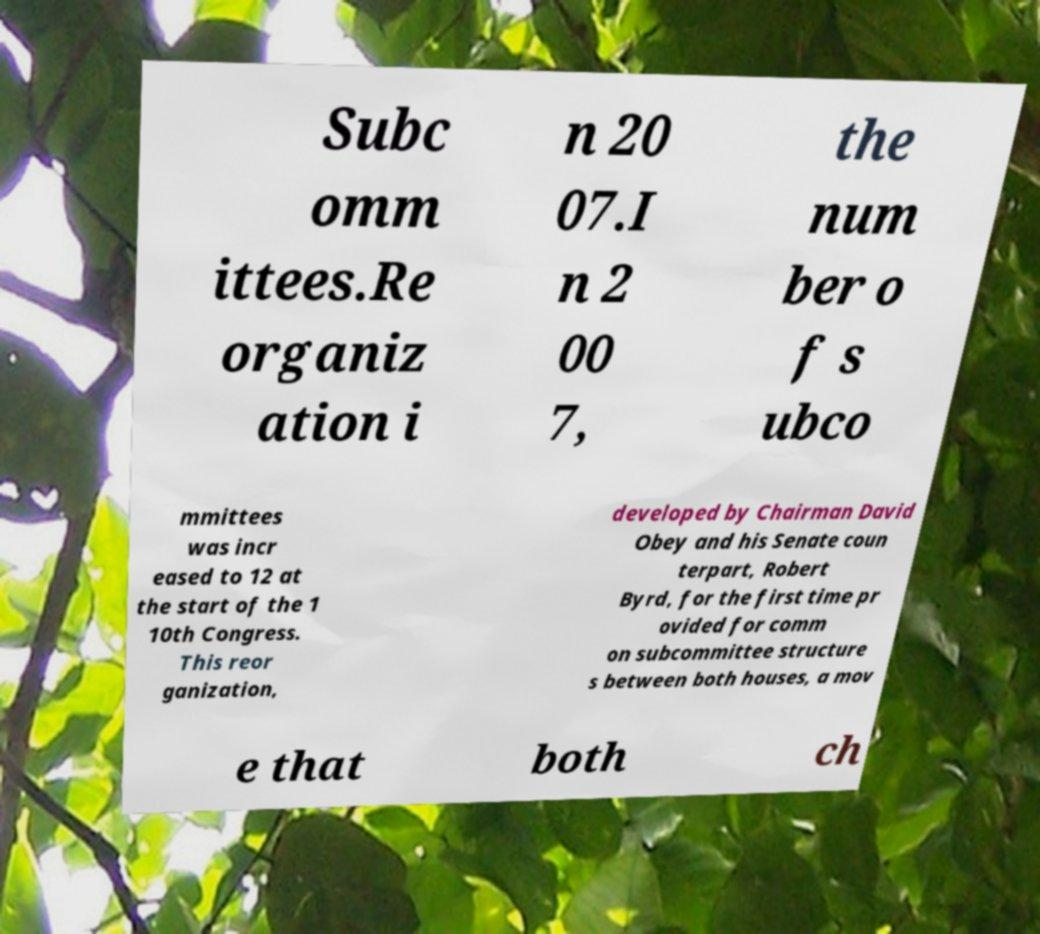Could you extract and type out the text from this image? Subc omm ittees.Re organiz ation i n 20 07.I n 2 00 7, the num ber o f s ubco mmittees was incr eased to 12 at the start of the 1 10th Congress. This reor ganization, developed by Chairman David Obey and his Senate coun terpart, Robert Byrd, for the first time pr ovided for comm on subcommittee structure s between both houses, a mov e that both ch 